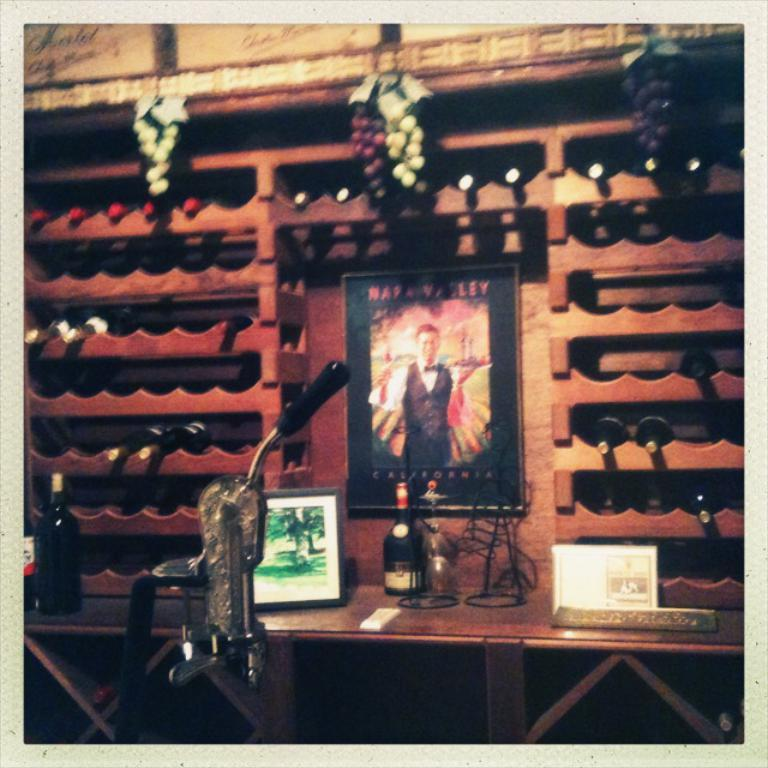<image>
Create a compact narrative representing the image presented. A wine cellar with grapes has a sign that says napa valley. 